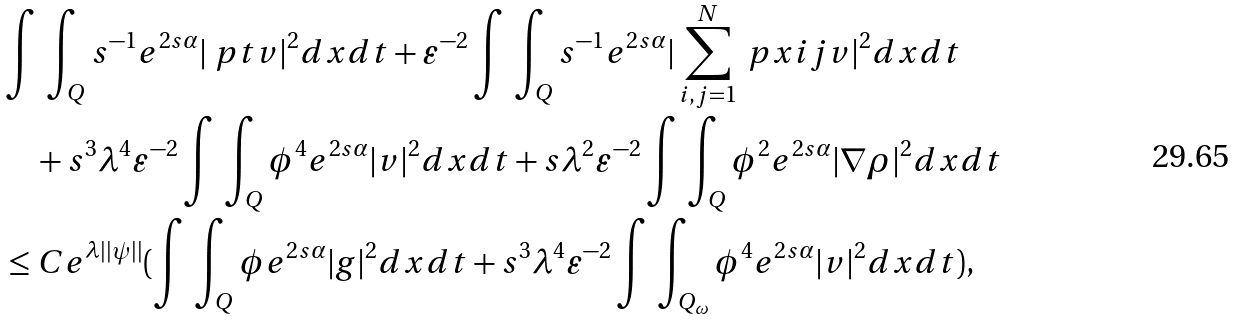Convert formula to latex. <formula><loc_0><loc_0><loc_500><loc_500>& \int \, \int _ { Q } s ^ { - 1 } e ^ { 2 s \alpha } | \ p t v | ^ { 2 } d x d t + \varepsilon ^ { - 2 } \int \, \int _ { Q } s ^ { - 1 } e ^ { 2 s \alpha } | \sum _ { i , j = 1 } ^ { N } \ p x i j v | ^ { 2 } d x d t \\ & \quad + s ^ { 3 } \lambda ^ { 4 } \varepsilon ^ { - 2 } \int \, \int _ { Q } \phi ^ { 4 } e ^ { 2 s \alpha } | v | ^ { 2 } d x d t + s \lambda ^ { 2 } \varepsilon ^ { - 2 } \int \, \int _ { Q } \phi ^ { 2 } e ^ { 2 s \alpha } | \nabla \rho | ^ { 2 } d x d t \\ & \leq C e ^ { \lambda | | \psi | | } ( \int \, \int _ { Q } \phi e ^ { 2 s \alpha } | g | ^ { 2 } d x d t + s ^ { 3 } \lambda ^ { 4 } \varepsilon ^ { - 2 } \int \, \int _ { Q _ { \omega } } \phi ^ { 4 } e ^ { 2 s \alpha } | v | ^ { 2 } d x d t ) ,</formula> 